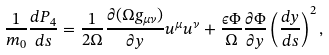<formula> <loc_0><loc_0><loc_500><loc_500>\frac { 1 } { m _ { 0 } } \frac { d P _ { 4 } } { d s } = \frac { 1 } { 2 \Omega } \frac { \partial ( \Omega g _ { \mu \nu } ) } { \partial y } u ^ { \mu } u ^ { \nu } + \frac { \epsilon \Phi } { \Omega } \frac { \partial \Phi } { \partial y } \left ( \frac { d y } { d s } \right ) ^ { 2 } ,</formula> 